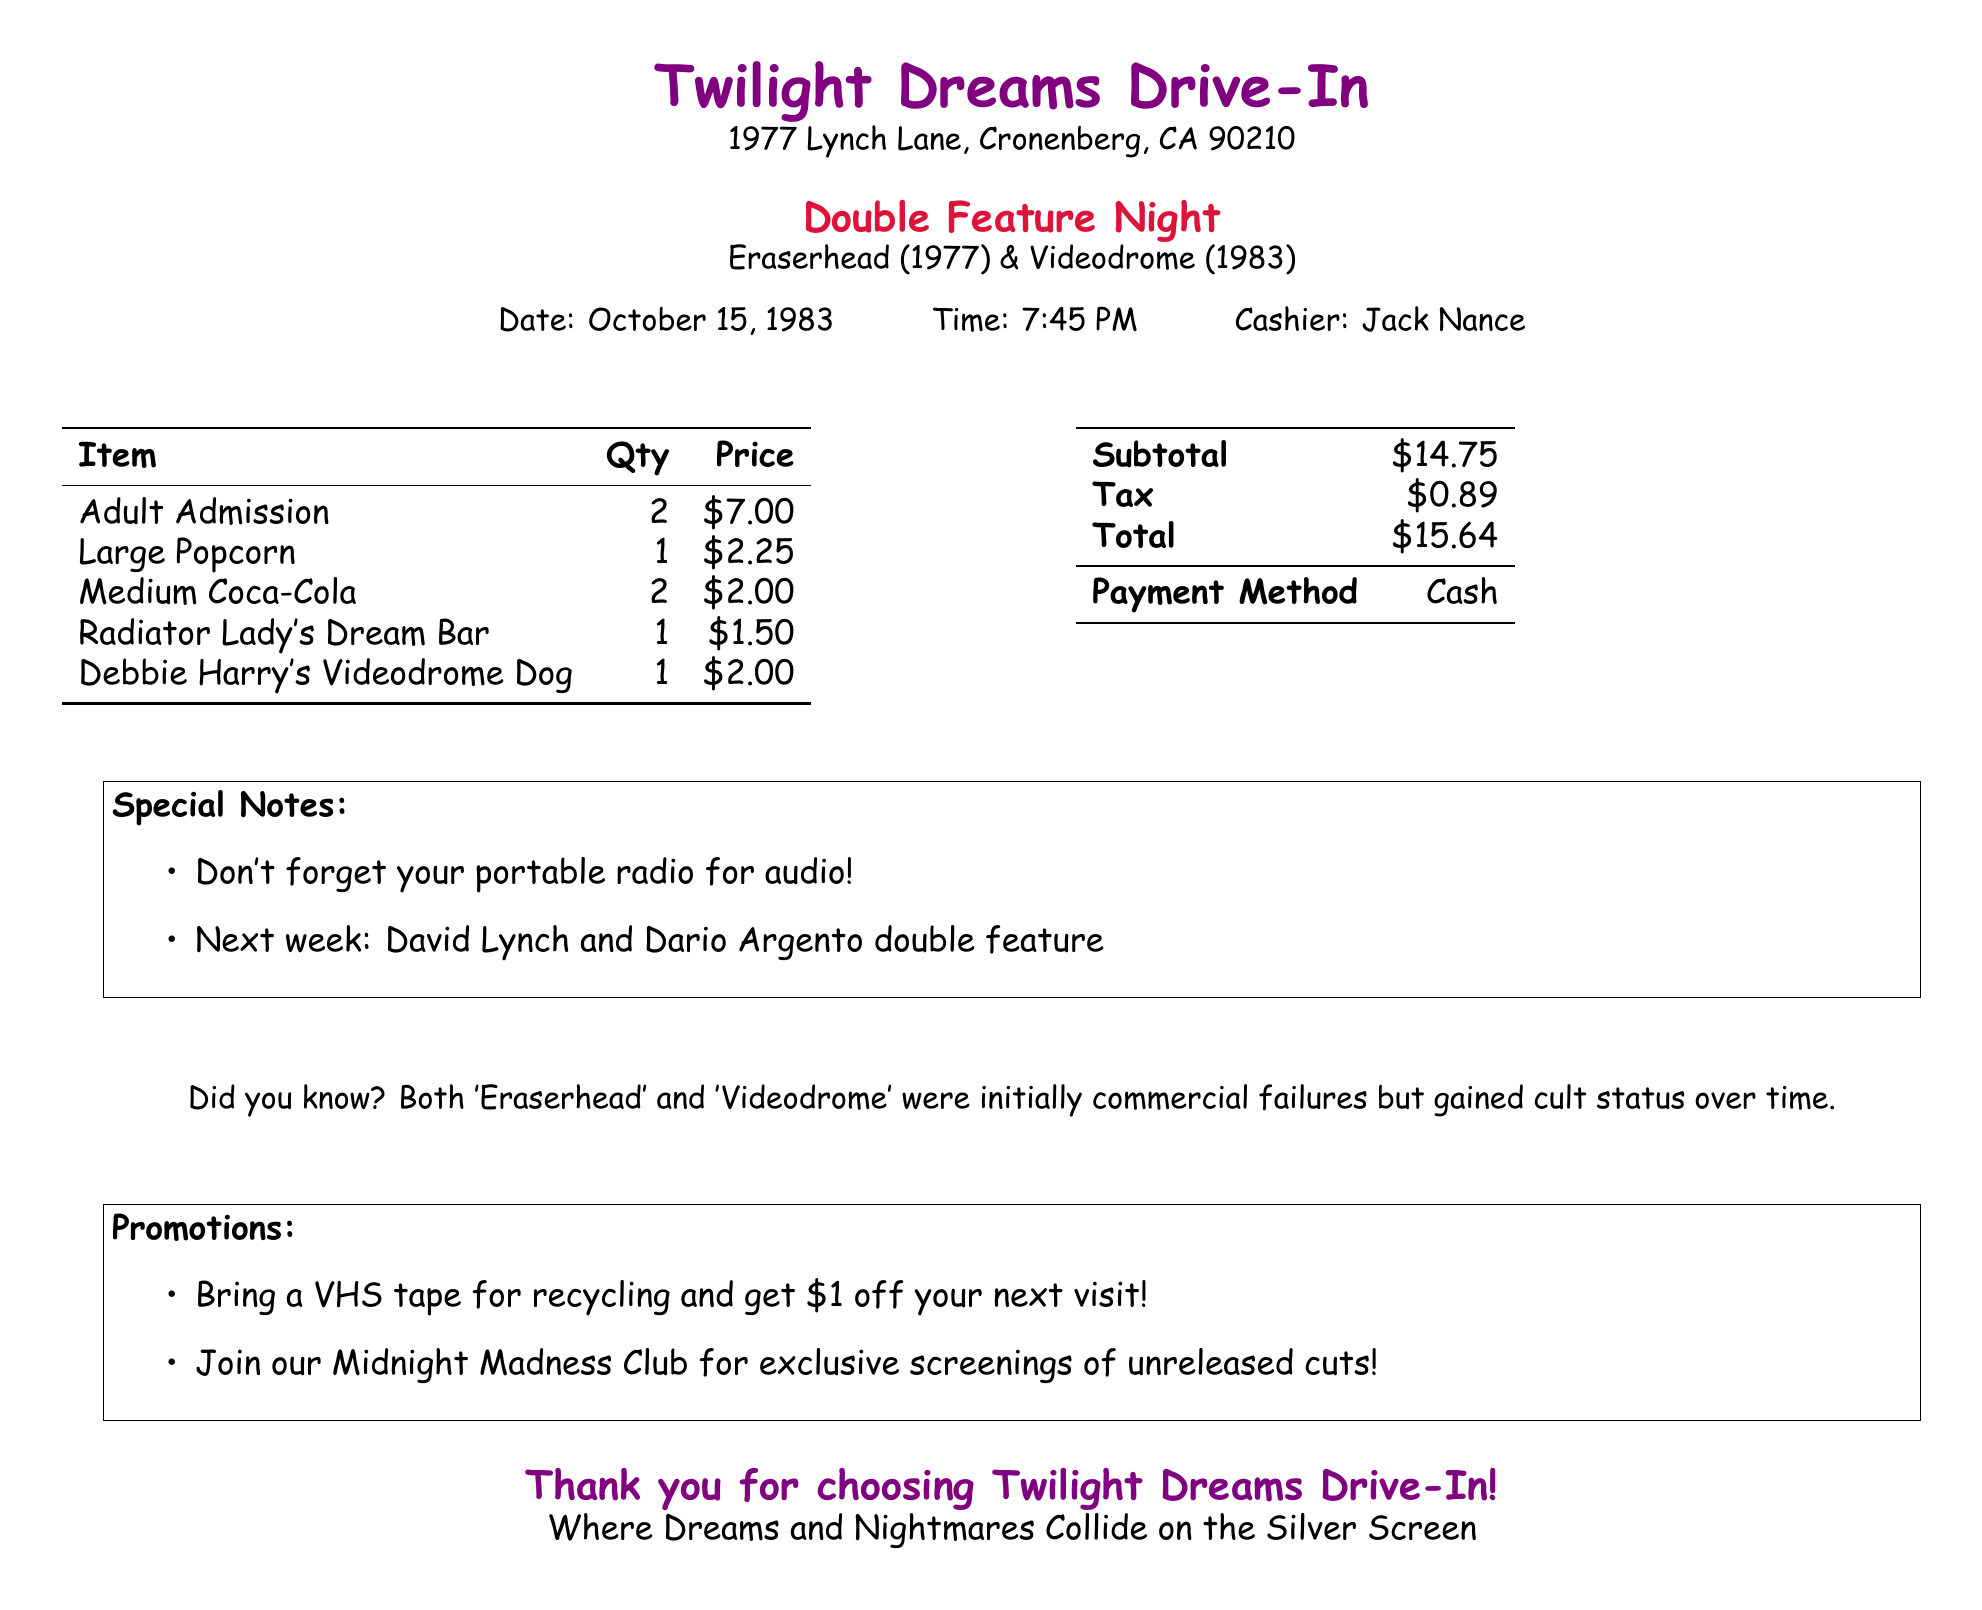What is the theater's name? The theater's name is prominently displayed at the top of the document.
Answer: Twilight Dreams Drive-In Who was the cashier? The cashier's name can be found in the details section of the receipt.
Answer: Jack Nance What date was the double feature? The date is listed at the top of the document along with the time.
Answer: October 15, 1983 How many Medium Coca-Colas were purchased? The quantity of each item is specified in the itemized list.
Answer: 2 What is the subtotal amount? The subtotal is recorded in the financial section of the receipt.
Answer: $14.75 What special note reminds customers about the audio? A special note is provided in a boxed area containing specific reminders.
Answer: Don't forget your portable radio for audio! What is the total payment amount? The total is the final amount calculated after tax, indicated in the financial section.
Answer: $15.64 What item features Debbie Harry? The item list includes specific food items with names referencing cultural icons.
Answer: Debbie Harry's Videodrome Dog What promotion is offered for VHS tape recycling? The promotions section has details about discounts associated with bringing a VHS tape.
Answer: $1 off your next visit 